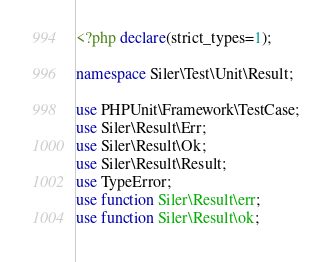Convert code to text. <code><loc_0><loc_0><loc_500><loc_500><_PHP_><?php declare(strict_types=1);

namespace Siler\Test\Unit\Result;

use PHPUnit\Framework\TestCase;
use Siler\Result\Err;
use Siler\Result\Ok;
use Siler\Result\Result;
use TypeError;
use function Siler\Result\err;
use function Siler\Result\ok;
</code> 